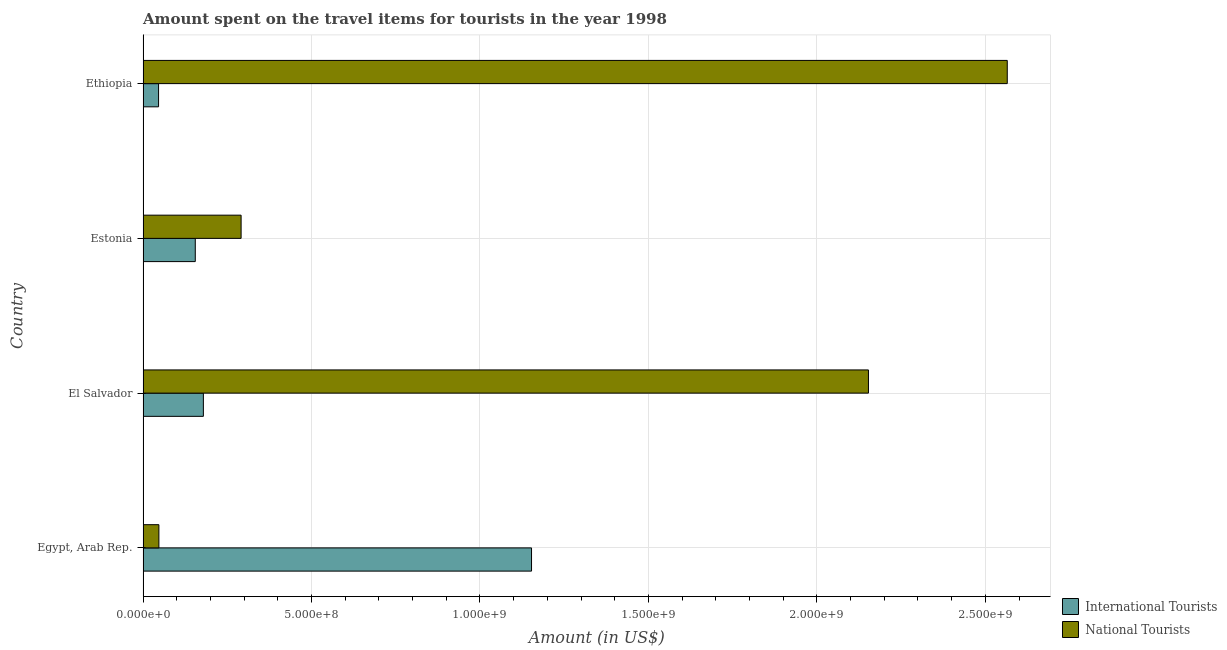How many groups of bars are there?
Your answer should be very brief. 4. What is the label of the 4th group of bars from the top?
Provide a succinct answer. Egypt, Arab Rep. What is the amount spent on travel items of international tourists in Egypt, Arab Rep.?
Keep it short and to the point. 1.15e+09. Across all countries, what is the maximum amount spent on travel items of international tourists?
Give a very brief answer. 1.15e+09. Across all countries, what is the minimum amount spent on travel items of national tourists?
Provide a short and direct response. 4.70e+07. In which country was the amount spent on travel items of international tourists maximum?
Keep it short and to the point. Egypt, Arab Rep. In which country was the amount spent on travel items of international tourists minimum?
Your answer should be compact. Ethiopia. What is the total amount spent on travel items of national tourists in the graph?
Provide a short and direct response. 5.06e+09. What is the difference between the amount spent on travel items of national tourists in Egypt, Arab Rep. and that in Ethiopia?
Your response must be concise. -2.52e+09. What is the difference between the amount spent on travel items of national tourists in Estonia and the amount spent on travel items of international tourists in Ethiopia?
Make the answer very short. 2.45e+08. What is the average amount spent on travel items of international tourists per country?
Offer a terse response. 3.83e+08. What is the difference between the amount spent on travel items of international tourists and amount spent on travel items of national tourists in El Salvador?
Give a very brief answer. -1.97e+09. What is the ratio of the amount spent on travel items of international tourists in Egypt, Arab Rep. to that in El Salvador?
Your answer should be very brief. 6.44. What is the difference between the highest and the second highest amount spent on travel items of international tourists?
Make the answer very short. 9.74e+08. What is the difference between the highest and the lowest amount spent on travel items of national tourists?
Offer a very short reply. 2.52e+09. What does the 1st bar from the top in Egypt, Arab Rep. represents?
Make the answer very short. National Tourists. What does the 2nd bar from the bottom in Estonia represents?
Your response must be concise. National Tourists. Does the graph contain grids?
Make the answer very short. Yes. How many legend labels are there?
Keep it short and to the point. 2. How are the legend labels stacked?
Your answer should be very brief. Vertical. What is the title of the graph?
Your response must be concise. Amount spent on the travel items for tourists in the year 1998. Does "Netherlands" appear as one of the legend labels in the graph?
Make the answer very short. No. What is the label or title of the X-axis?
Your answer should be compact. Amount (in US$). What is the label or title of the Y-axis?
Keep it short and to the point. Country. What is the Amount (in US$) in International Tourists in Egypt, Arab Rep.?
Your answer should be compact. 1.15e+09. What is the Amount (in US$) in National Tourists in Egypt, Arab Rep.?
Provide a short and direct response. 4.70e+07. What is the Amount (in US$) of International Tourists in El Salvador?
Keep it short and to the point. 1.79e+08. What is the Amount (in US$) of National Tourists in El Salvador?
Provide a succinct answer. 2.15e+09. What is the Amount (in US$) of International Tourists in Estonia?
Your answer should be compact. 1.55e+08. What is the Amount (in US$) in National Tourists in Estonia?
Your answer should be very brief. 2.91e+08. What is the Amount (in US$) in International Tourists in Ethiopia?
Offer a terse response. 4.60e+07. What is the Amount (in US$) in National Tourists in Ethiopia?
Provide a succinct answer. 2.56e+09. Across all countries, what is the maximum Amount (in US$) in International Tourists?
Offer a terse response. 1.15e+09. Across all countries, what is the maximum Amount (in US$) of National Tourists?
Provide a succinct answer. 2.56e+09. Across all countries, what is the minimum Amount (in US$) of International Tourists?
Your answer should be very brief. 4.60e+07. Across all countries, what is the minimum Amount (in US$) of National Tourists?
Your answer should be compact. 4.70e+07. What is the total Amount (in US$) of International Tourists in the graph?
Provide a succinct answer. 1.53e+09. What is the total Amount (in US$) of National Tourists in the graph?
Your answer should be very brief. 5.06e+09. What is the difference between the Amount (in US$) of International Tourists in Egypt, Arab Rep. and that in El Salvador?
Make the answer very short. 9.74e+08. What is the difference between the Amount (in US$) of National Tourists in Egypt, Arab Rep. and that in El Salvador?
Your answer should be very brief. -2.11e+09. What is the difference between the Amount (in US$) of International Tourists in Egypt, Arab Rep. and that in Estonia?
Keep it short and to the point. 9.98e+08. What is the difference between the Amount (in US$) in National Tourists in Egypt, Arab Rep. and that in Estonia?
Your response must be concise. -2.44e+08. What is the difference between the Amount (in US$) in International Tourists in Egypt, Arab Rep. and that in Ethiopia?
Make the answer very short. 1.11e+09. What is the difference between the Amount (in US$) in National Tourists in Egypt, Arab Rep. and that in Ethiopia?
Your answer should be compact. -2.52e+09. What is the difference between the Amount (in US$) in International Tourists in El Salvador and that in Estonia?
Give a very brief answer. 2.40e+07. What is the difference between the Amount (in US$) in National Tourists in El Salvador and that in Estonia?
Ensure brevity in your answer.  1.86e+09. What is the difference between the Amount (in US$) in International Tourists in El Salvador and that in Ethiopia?
Make the answer very short. 1.33e+08. What is the difference between the Amount (in US$) of National Tourists in El Salvador and that in Ethiopia?
Provide a succinct answer. -4.12e+08. What is the difference between the Amount (in US$) in International Tourists in Estonia and that in Ethiopia?
Your answer should be very brief. 1.09e+08. What is the difference between the Amount (in US$) in National Tourists in Estonia and that in Ethiopia?
Ensure brevity in your answer.  -2.27e+09. What is the difference between the Amount (in US$) in International Tourists in Egypt, Arab Rep. and the Amount (in US$) in National Tourists in El Salvador?
Your answer should be very brief. -1.00e+09. What is the difference between the Amount (in US$) in International Tourists in Egypt, Arab Rep. and the Amount (in US$) in National Tourists in Estonia?
Offer a very short reply. 8.62e+08. What is the difference between the Amount (in US$) of International Tourists in Egypt, Arab Rep. and the Amount (in US$) of National Tourists in Ethiopia?
Make the answer very short. -1.41e+09. What is the difference between the Amount (in US$) of International Tourists in El Salvador and the Amount (in US$) of National Tourists in Estonia?
Your answer should be very brief. -1.12e+08. What is the difference between the Amount (in US$) of International Tourists in El Salvador and the Amount (in US$) of National Tourists in Ethiopia?
Provide a short and direct response. -2.39e+09. What is the difference between the Amount (in US$) in International Tourists in Estonia and the Amount (in US$) in National Tourists in Ethiopia?
Your answer should be very brief. -2.41e+09. What is the average Amount (in US$) of International Tourists per country?
Offer a terse response. 3.83e+08. What is the average Amount (in US$) in National Tourists per country?
Provide a succinct answer. 1.26e+09. What is the difference between the Amount (in US$) of International Tourists and Amount (in US$) of National Tourists in Egypt, Arab Rep.?
Make the answer very short. 1.11e+09. What is the difference between the Amount (in US$) in International Tourists and Amount (in US$) in National Tourists in El Salvador?
Keep it short and to the point. -1.97e+09. What is the difference between the Amount (in US$) in International Tourists and Amount (in US$) in National Tourists in Estonia?
Give a very brief answer. -1.36e+08. What is the difference between the Amount (in US$) in International Tourists and Amount (in US$) in National Tourists in Ethiopia?
Your answer should be very brief. -2.52e+09. What is the ratio of the Amount (in US$) of International Tourists in Egypt, Arab Rep. to that in El Salvador?
Offer a terse response. 6.44. What is the ratio of the Amount (in US$) in National Tourists in Egypt, Arab Rep. to that in El Salvador?
Provide a succinct answer. 0.02. What is the ratio of the Amount (in US$) in International Tourists in Egypt, Arab Rep. to that in Estonia?
Provide a short and direct response. 7.44. What is the ratio of the Amount (in US$) of National Tourists in Egypt, Arab Rep. to that in Estonia?
Offer a terse response. 0.16. What is the ratio of the Amount (in US$) in International Tourists in Egypt, Arab Rep. to that in Ethiopia?
Offer a terse response. 25.07. What is the ratio of the Amount (in US$) of National Tourists in Egypt, Arab Rep. to that in Ethiopia?
Provide a succinct answer. 0.02. What is the ratio of the Amount (in US$) in International Tourists in El Salvador to that in Estonia?
Make the answer very short. 1.15. What is the ratio of the Amount (in US$) of National Tourists in El Salvador to that in Estonia?
Your answer should be compact. 7.4. What is the ratio of the Amount (in US$) in International Tourists in El Salvador to that in Ethiopia?
Make the answer very short. 3.89. What is the ratio of the Amount (in US$) in National Tourists in El Salvador to that in Ethiopia?
Provide a short and direct response. 0.84. What is the ratio of the Amount (in US$) in International Tourists in Estonia to that in Ethiopia?
Make the answer very short. 3.37. What is the ratio of the Amount (in US$) of National Tourists in Estonia to that in Ethiopia?
Provide a short and direct response. 0.11. What is the difference between the highest and the second highest Amount (in US$) of International Tourists?
Your response must be concise. 9.74e+08. What is the difference between the highest and the second highest Amount (in US$) of National Tourists?
Offer a very short reply. 4.12e+08. What is the difference between the highest and the lowest Amount (in US$) in International Tourists?
Offer a very short reply. 1.11e+09. What is the difference between the highest and the lowest Amount (in US$) of National Tourists?
Keep it short and to the point. 2.52e+09. 